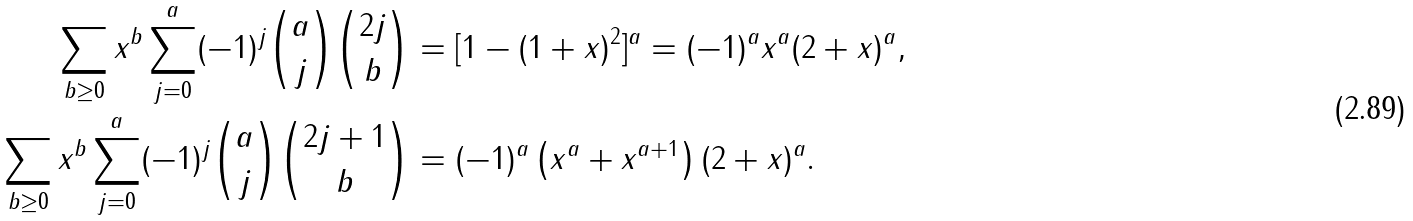Convert formula to latex. <formula><loc_0><loc_0><loc_500><loc_500>\sum _ { b \geq 0 } x ^ { b } \sum _ { j = 0 } ^ { a } ( - 1 ) ^ { j } \binom { a } { j } \binom { 2 j } { b } & = [ 1 - ( 1 + x ) ^ { 2 } ] ^ { a } = ( - 1 ) ^ { a } x ^ { a } ( 2 + x ) ^ { a } , \\ \sum _ { b \geq 0 } x ^ { b } \sum _ { j = 0 } ^ { a } ( - 1 ) ^ { j } \binom { a } { j } \binom { 2 j + 1 } { b } & = ( - 1 ) ^ { a } \left ( x ^ { a } + x ^ { a + 1 } \right ) ( 2 + x ) ^ { a } .</formula> 